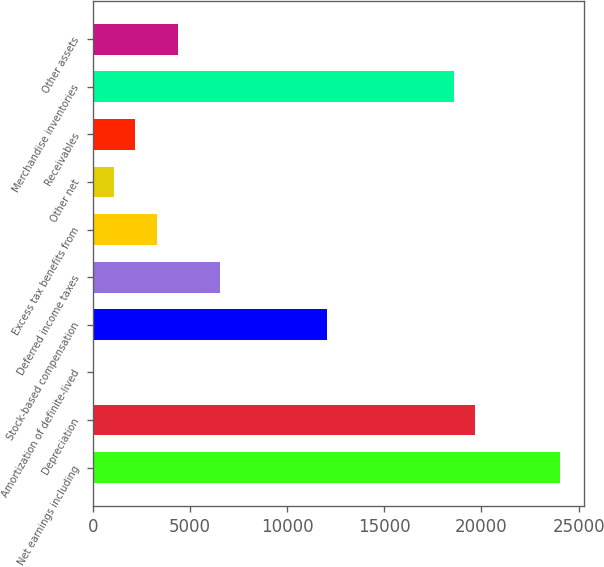Convert chart to OTSL. <chart><loc_0><loc_0><loc_500><loc_500><bar_chart><fcel>Net earnings including<fcel>Depreciation<fcel>Amortization of definite-lived<fcel>Stock-based compensation<fcel>Deferred income taxes<fcel>Excess tax benefits from<fcel>Other net<fcel>Receivables<fcel>Merchandise inventories<fcel>Other assets<nl><fcel>24055.8<fcel>19682.2<fcel>1<fcel>12028.4<fcel>6561.4<fcel>3281.2<fcel>1094.4<fcel>2187.8<fcel>18588.8<fcel>4374.6<nl></chart> 